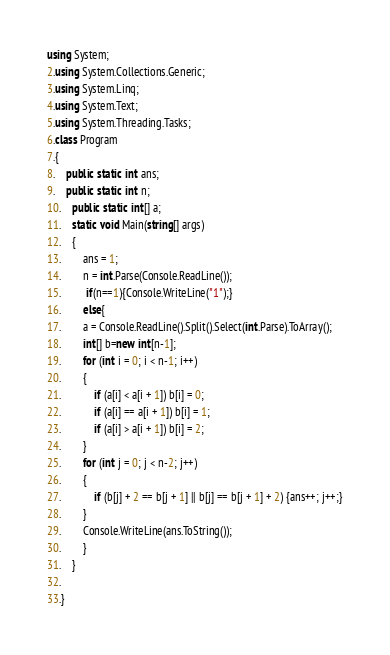Convert code to text. <code><loc_0><loc_0><loc_500><loc_500><_C#_>using System;
2.using System.Collections.Generic;
3.using System.Linq;
4.using System.Text;
5.using System.Threading.Tasks;
6.class Program
7.{
8.    public static int ans;
9.    public static int n;
10.    public static int[] a;
11.    static void Main(string[] args)
12.    {
13.        ans = 1;
14.        n = int.Parse(Console.ReadLine());
15.         if(n==1){Console.WriteLine("1");}
16.        else{
17.        a = Console.ReadLine().Split().Select(int.Parse).ToArray();
18.        int[] b=new int[n-1];
19.        for (int i = 0; i < n-1; i++)
20.        {
21.            if (a[i] < a[i + 1]) b[i] = 0;
22.            if (a[i] == a[i + 1]) b[i] = 1;
23.            if (a[i] > a[i + 1]) b[i] = 2;
24.        }
25.        for (int j = 0; j < n-2; j++)
26.        {
27.            if (b[j] + 2 == b[j + 1] || b[j] == b[j + 1] + 2) {ans++; j++;}
28.        }
29.        Console.WriteLine(ans.ToString());
30.        }
31.    }
32.    
33.}
</code> 